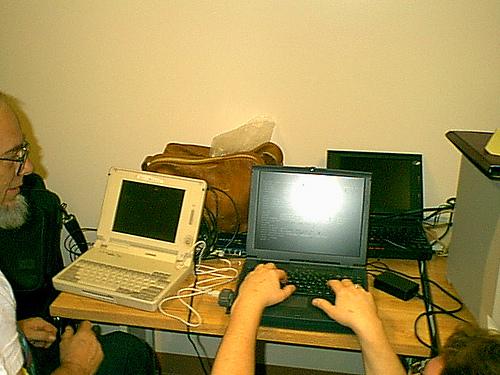What color is the bag on the left?
Short answer required. Brown. How many laptops can be counted?
Quick response, please. 3. Is the laptop on the left on?
Quick response, please. No. 